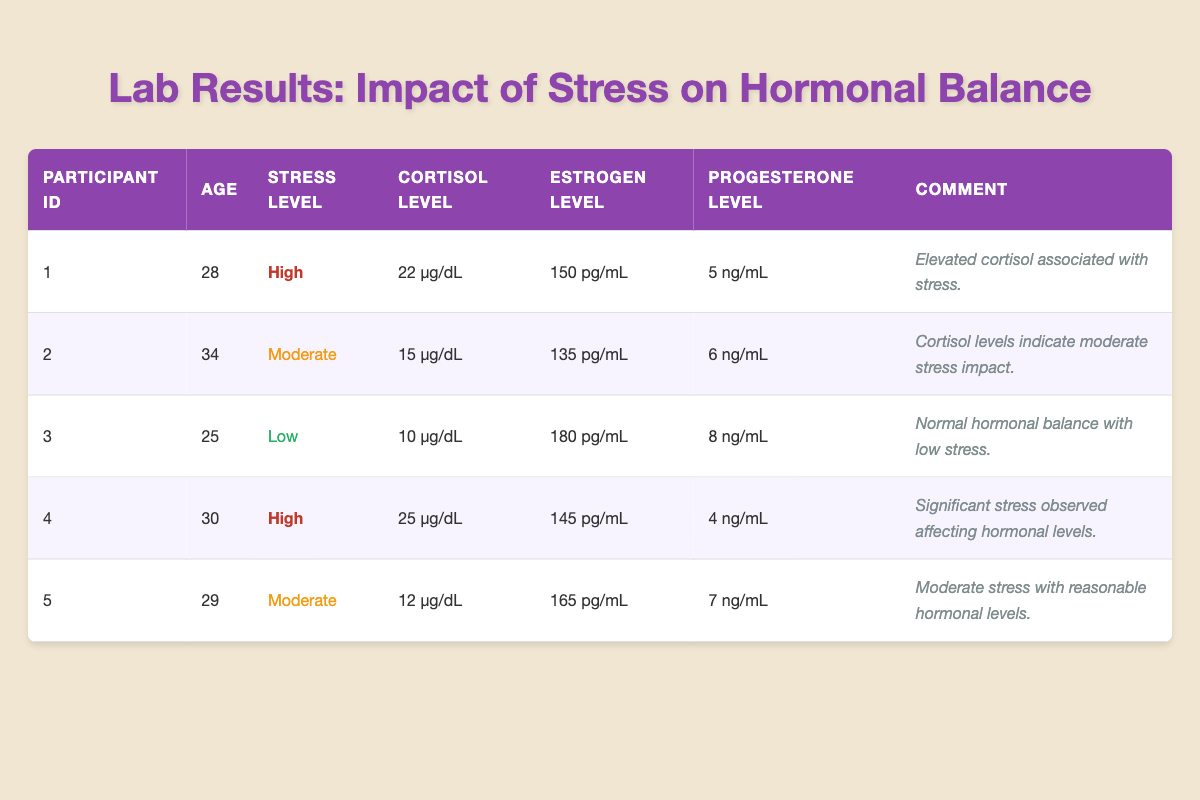What's the cortisol level of the participant with the highest stress? The participant with the highest stress level is Participant 4, whose cortisol level is noted as 25 µg/dL.
Answer: 25 µg/dL What is the estrogen level of the participant with the lowest stress? Participant 3 has the lowest stress level, which is low, and their estrogen level is 180 pg/mL.
Answer: 180 pg/mL Is there a participant with a moderate stress level who has a cortisol level over 15 µg/dL? Participant 2 has a cortisol level of 15 µg/dL and is classified as moderate stress, while Participant 5 has a cortisol level of 12 µg/dL, which does not exceed 15 µg/dL. Therefore, there is no participant with moderate stress who has a cortisol level over 15 µg/dL.
Answer: No What is the average progesterone level of participants with high stress? Participants 1 and 4 have high stress. Their progesterone levels are 5 ng/mL (Participant 1) and 4 ng/mL (Participant 4). The average is calculated as (5 + 4) / 2 = 4.5 ng/mL.
Answer: 4.5 ng/mL How many participants have estrogen levels above 150 pg/mL? Participants 1, 3, and 5 have estrogen levels of 150 pg/mL, 180 pg/mL, and 165 pg/mL, respectively. Therefore, there are 3 participants with estrogen levels above 150 pg/mL.
Answer: 3 What participant shows significant stress impacting hormonal levels? Participant 4 is described in the comment as having "Significant stress observed affecting hormonal levels".
Answer: Participant 4 Which participant is the youngest, and what is their stress level? Participant 3 is the youngest at 25 years old and has a low stress level.
Answer: 25 years old, Low stress Is the average cortisol level among participants with moderate stress higher than that of those with low stress? The average cortisol level for moderate stress (Participants 2 and 5) is (15 + 12) / 2 = 13.5 µg/dL. For low stress (Participant 3), the cortisol level is 10 µg/dL. Since 13.5 µg/dL is higher than 10 µg/dL, the average cortisol level for moderate stress is higher.
Answer: Yes 